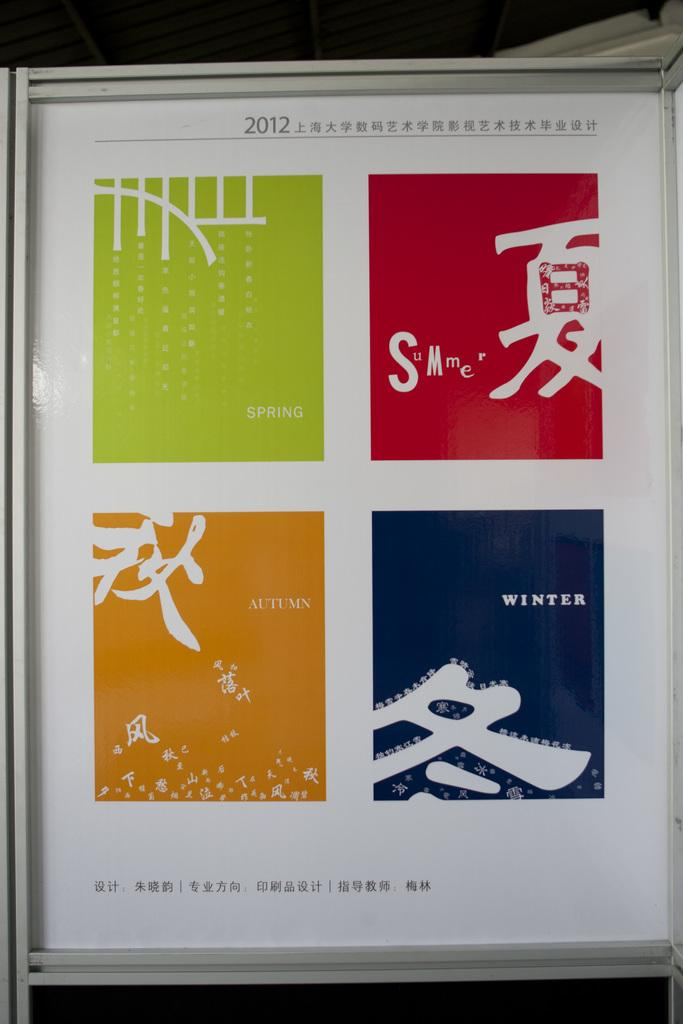<image>
Present a compact description of the photo's key features. Different colored boxes represent the four seasons: spring, summer, autumn, and winter. 